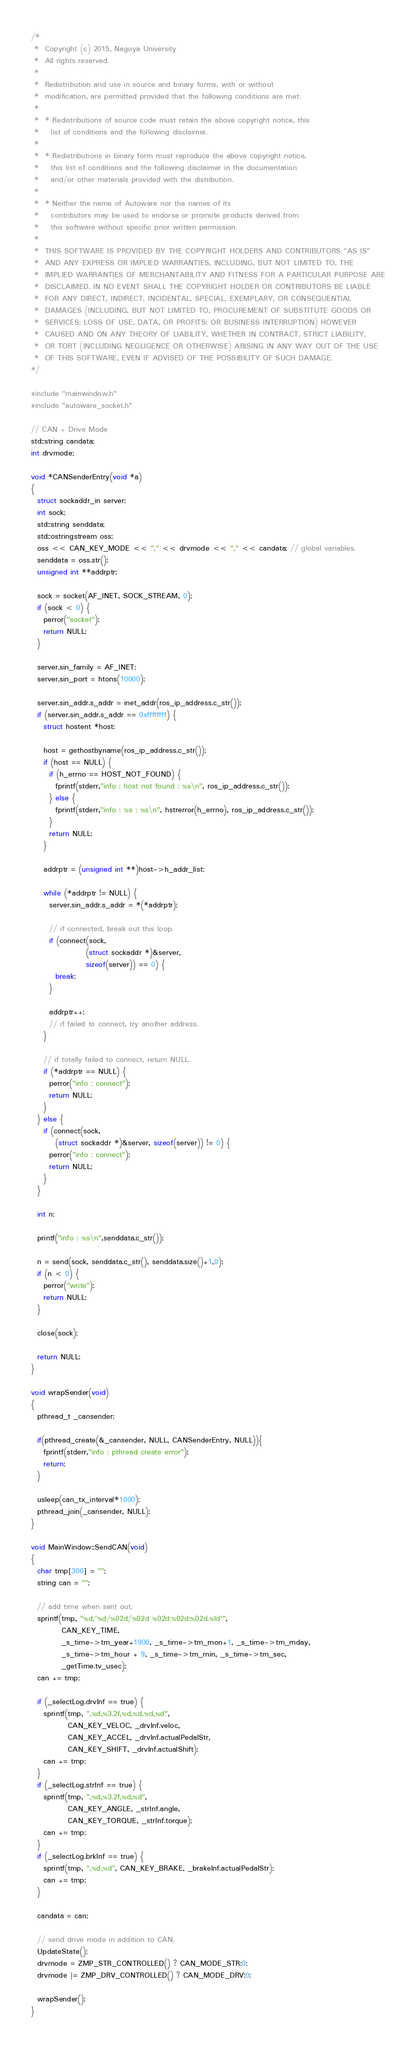<code> <loc_0><loc_0><loc_500><loc_500><_C++_>/*
 *  Copyright (c) 2015, Nagoya University
 *  All rights reserved.
 *
 *  Redistribution and use in source and binary forms, with or without
 *  modification, are permitted provided that the following conditions are met:
 *
 *  * Redistributions of source code must retain the above copyright notice, this
 *    list of conditions and the following disclaimer.
 *
 *  * Redistributions in binary form must reproduce the above copyright notice,
 *    this list of conditions and the following disclaimer in the documentation
 *    and/or other materials provided with the distribution.
 *
 *  * Neither the name of Autoware nor the names of its
 *    contributors may be used to endorse or promote products derived from
 *    this software without specific prior written permission.
 *
 *  THIS SOFTWARE IS PROVIDED BY THE COPYRIGHT HOLDERS AND CONTRIBUTORS "AS IS"
 *  AND ANY EXPRESS OR IMPLIED WARRANTIES, INCLUDING, BUT NOT LIMITED TO, THE
 *  IMPLIED WARRANTIES OF MERCHANTABILITY AND FITNESS FOR A PARTICULAR PURPOSE ARE
 *  DISCLAIMED. IN NO EVENT SHALL THE COPYRIGHT HOLDER OR CONTRIBUTORS BE LIABLE
 *  FOR ANY DIRECT, INDIRECT, INCIDENTAL, SPECIAL, EXEMPLARY, OR CONSEQUENTIAL
 *  DAMAGES (INCLUDING, BUT NOT LIMITED TO, PROCUREMENT OF SUBSTITUTE GOODS OR
 *  SERVICES; LOSS OF USE, DATA, OR PROFITS; OR BUSINESS INTERRUPTION) HOWEVER
 *  CAUSED AND ON ANY THEORY OF LIABILITY, WHETHER IN CONTRACT, STRICT LIABILITY,
 *  OR TORT (INCLUDING NEGLIGENCE OR OTHERWISE) ARISING IN ANY WAY OUT OF THE USE
 *  OF THIS SOFTWARE, EVEN IF ADVISED OF THE POSSIBILITY OF SUCH DAMAGE.
*/

#include "mainwindow.h"
#include "autoware_socket.h"

// CAN + Drive Mode
std::string candata;
int drvmode;

void *CANSenderEntry(void *a)
{
  struct sockaddr_in server;
  int sock;
  std::string senddata; 
  std::ostringstream oss;
  oss << CAN_KEY_MODE << "," << drvmode << "," << candata; // global variables.
  senddata = oss.str();
  unsigned int **addrptr;

  sock = socket(AF_INET, SOCK_STREAM, 0);
  if (sock < 0) {
    perror("socket");
    return NULL;
  }

  server.sin_family = AF_INET;
  server.sin_port = htons(10000);

  server.sin_addr.s_addr = inet_addr(ros_ip_address.c_str());
  if (server.sin_addr.s_addr == 0xffffffff) {
    struct hostent *host;

    host = gethostbyname(ros_ip_address.c_str());
    if (host == NULL) {
      if (h_errno == HOST_NOT_FOUND) {
        fprintf(stderr,"info : host not found : %s\n", ros_ip_address.c_str());
      } else {
        fprintf(stderr,"info : %s : %s\n", hstrerror(h_errno), ros_ip_address.c_str());
      }
      return NULL;
    }

    addrptr = (unsigned int **)host->h_addr_list;

    while (*addrptr != NULL) {
      server.sin_addr.s_addr = *(*addrptr);
      
      // if connected, break out this loop.
      if (connect(sock,
                  (struct sockaddr *)&server,
                  sizeof(server)) == 0) {
        break;
      }

      addrptr++;
      // if failed to connect, try another address.
    }

    // if totally failed to connect, return NULL.
    if (*addrptr == NULL) {
      perror("info : connect");
      return NULL;
    }
  } else {
    if (connect(sock,
		(struct sockaddr *)&server, sizeof(server)) != 0) {
      perror("info : connect");
      return NULL;
    }
  }

  int n;

  printf("info : %s\n",senddata.c_str());
    
  n = send(sock, senddata.c_str(), senddata.size()+1,0);
  if (n < 0) {
    perror("write");
    return NULL;
  }
    
  close(sock);

  return NULL;
}

void wrapSender(void)
{
  pthread_t _cansender;
  
  if(pthread_create(&_cansender, NULL, CANSenderEntry, NULL)){
    fprintf(stderr,"info : pthread create error");
    return;
  }

  usleep(can_tx_interval*1000);
  pthread_join(_cansender, NULL);
}

void MainWindow::SendCAN(void)
{
  char tmp[300] = "";
  string can = "";

  // add time when sent out.
  sprintf(tmp, "%d,'%d/%02d/%02d %02d:%02d:%02d.%ld'",
          CAN_KEY_TIME,
          _s_time->tm_year+1900, _s_time->tm_mon+1, _s_time->tm_mday,
          _s_time->tm_hour + 9, _s_time->tm_min, _s_time->tm_sec, 
          _getTime.tv_usec);
  can += tmp;

  if (_selectLog.drvInf == true) {
    sprintf(tmp, ",%d,%3.2f,%d,%d,%d,%d",
            CAN_KEY_VELOC, _drvInf.veloc,
            CAN_KEY_ACCEL, _drvInf.actualPedalStr,
            CAN_KEY_SHIFT, _drvInf.actualShift);
    can += tmp;
  }
  if (_selectLog.strInf == true) {
    sprintf(tmp, ",%d,%3.2f,%d,%d",
            CAN_KEY_ANGLE, _strInf.angle,
            CAN_KEY_TORQUE, _strInf.torque);
    can += tmp;
  }
  if (_selectLog.brkInf == true) {
    sprintf(tmp, ",%d,%d", CAN_KEY_BRAKE, _brakeInf.actualPedalStr);
    can += tmp;
  }
  
  candata = can;

  // send drive mode in addition to CAN.
  UpdateState();
  drvmode = ZMP_STR_CONTROLLED() ? CAN_MODE_STR:0;
  drvmode |= ZMP_DRV_CONTROLLED() ? CAN_MODE_DRV:0;
  
  wrapSender();
}
</code> 